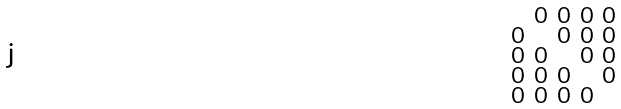<formula> <loc_0><loc_0><loc_500><loc_500>\begin{smallmatrix} & 0 & 0 & 0 & 0 \\ 0 & & 0 & 0 & 0 \\ 0 & 0 & & 0 & 0 \\ 0 & 0 & 0 & & 0 \\ 0 & 0 & 0 & 0 & \end{smallmatrix}</formula> 